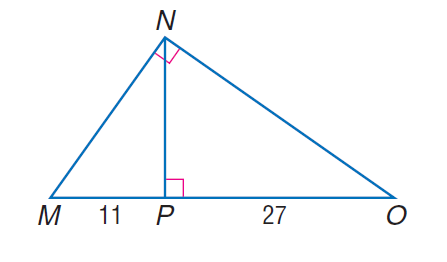Answer the mathemtical geometry problem and directly provide the correct option letter.
Question: Find the measure of the altitude drawn to the hypotenuse.
Choices: A: 11 B: \sqrt { 297 } C: 27 D: 297 B 